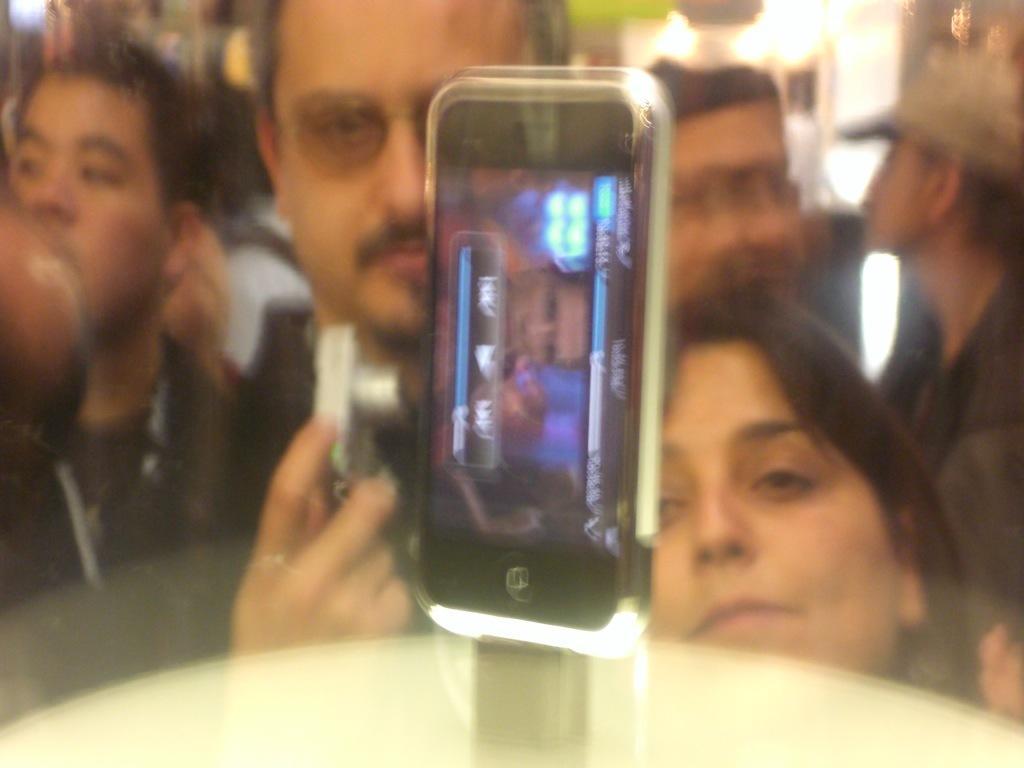Describe this image in one or two sentences. In this image in the center there is one mobile phone, it seems that the mobile phone is in glass box. And in the background there are a group of people, one person is holding a camera and also we could see some lights, wall and some objects. 